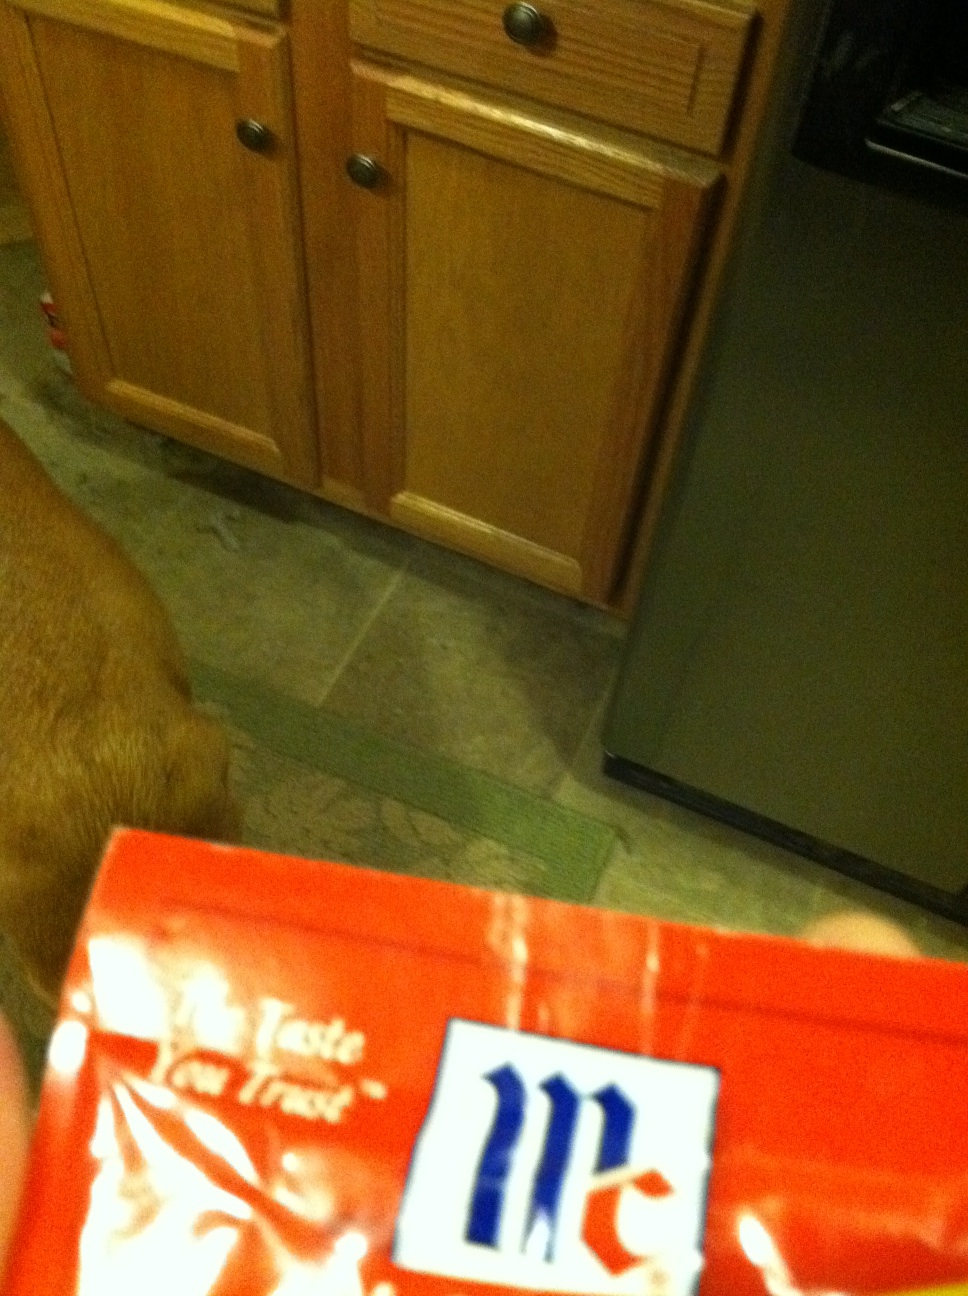What kind of dishes can typically use the content in this type of packet? Packets like this often contain sauces or seasoning mixes that can be used in a variety of dishes ranging from stir-fries to marinades for meat. They're versatile and can add a rich or spicy flavor depending on the specific content. 